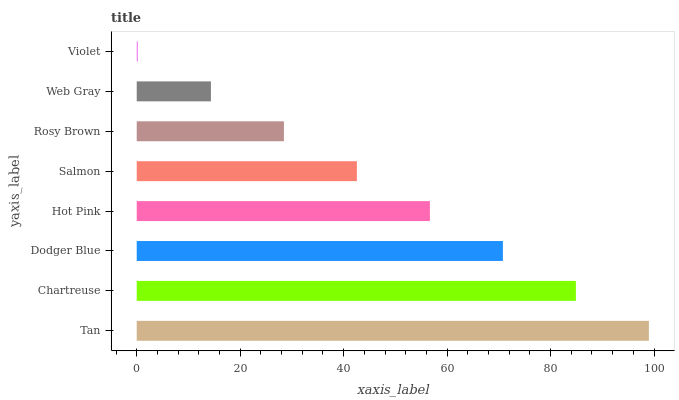Is Violet the minimum?
Answer yes or no. Yes. Is Tan the maximum?
Answer yes or no. Yes. Is Chartreuse the minimum?
Answer yes or no. No. Is Chartreuse the maximum?
Answer yes or no. No. Is Tan greater than Chartreuse?
Answer yes or no. Yes. Is Chartreuse less than Tan?
Answer yes or no. Yes. Is Chartreuse greater than Tan?
Answer yes or no. No. Is Tan less than Chartreuse?
Answer yes or no. No. Is Hot Pink the high median?
Answer yes or no. Yes. Is Salmon the low median?
Answer yes or no. Yes. Is Salmon the high median?
Answer yes or no. No. Is Chartreuse the low median?
Answer yes or no. No. 